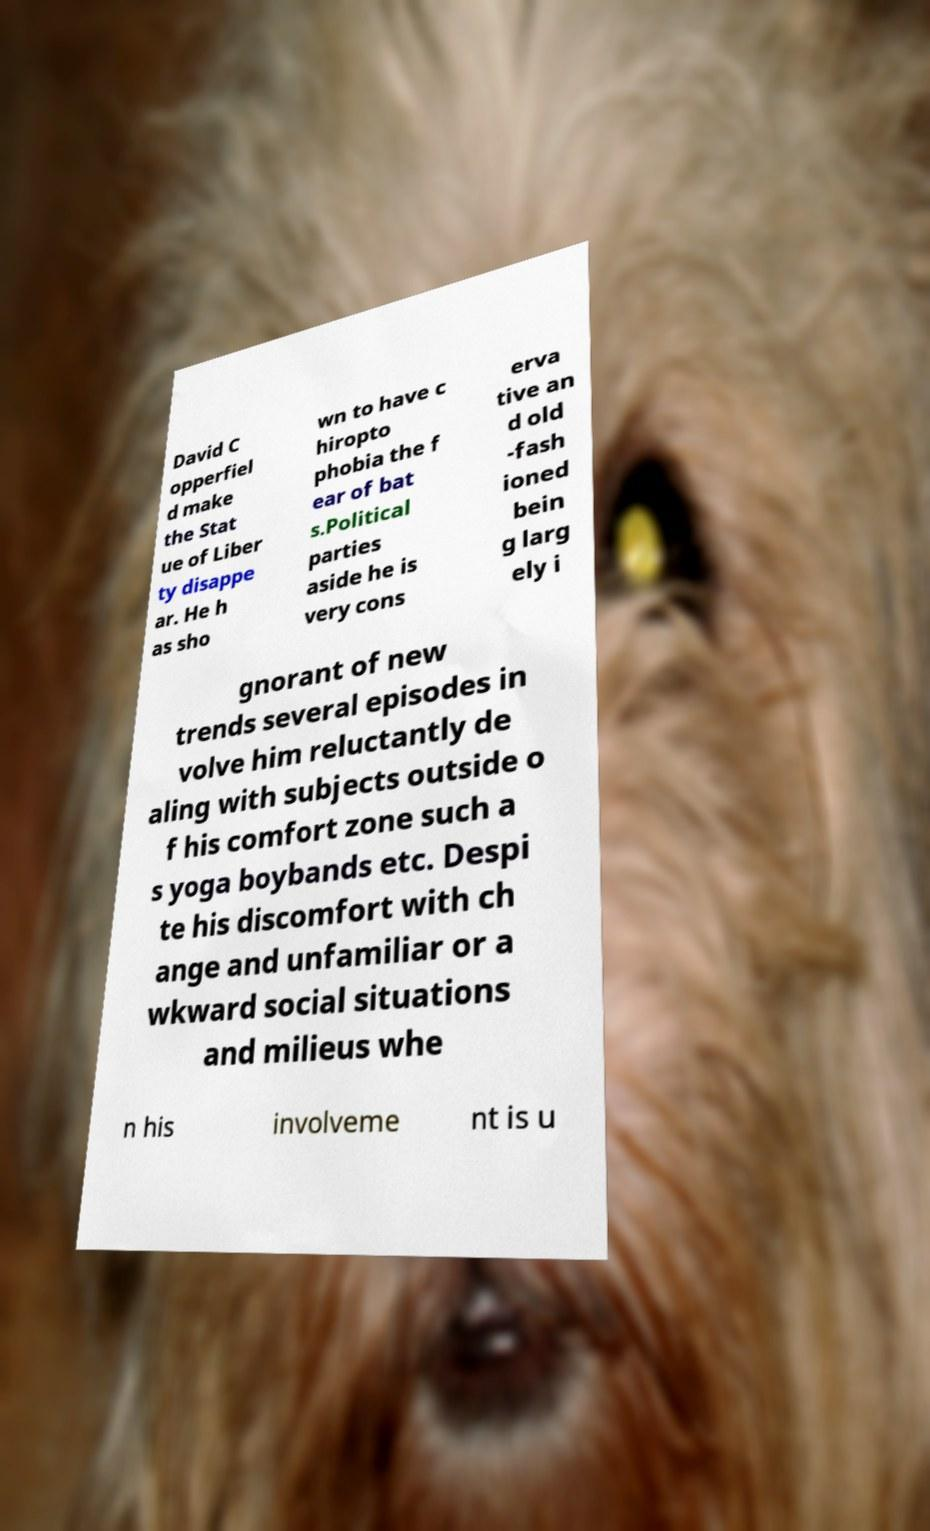Could you extract and type out the text from this image? David C opperfiel d make the Stat ue of Liber ty disappe ar. He h as sho wn to have c hiropto phobia the f ear of bat s.Political parties aside he is very cons erva tive an d old -fash ioned bein g larg ely i gnorant of new trends several episodes in volve him reluctantly de aling with subjects outside o f his comfort zone such a s yoga boybands etc. Despi te his discomfort with ch ange and unfamiliar or a wkward social situations and milieus whe n his involveme nt is u 